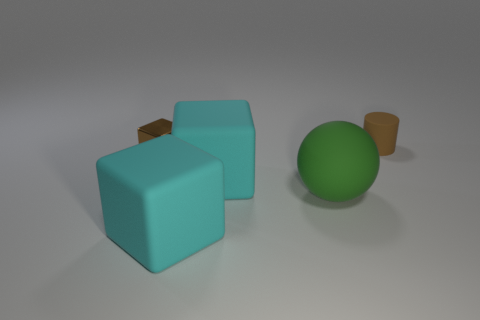There is a green thing that is made of the same material as the brown cylinder; what size is it?
Keep it short and to the point. Large. Is the number of tiny gray balls greater than the number of small brown matte cylinders?
Ensure brevity in your answer.  No. The large thing that is in front of the green object is what color?
Your response must be concise. Cyan. There is a cube that is both to the right of the small metallic thing and behind the large rubber ball; how big is it?
Make the answer very short. Large. What number of cyan cubes are the same size as the brown shiny cube?
Offer a terse response. 0. Does the big green object have the same shape as the brown metal thing?
Ensure brevity in your answer.  No. How many cyan matte cubes are in front of the rubber sphere?
Ensure brevity in your answer.  1. There is a brown thing that is on the right side of the green object that is right of the small metal object; what shape is it?
Your response must be concise. Cylinder. There is a small thing that is made of the same material as the large green sphere; what is its shape?
Make the answer very short. Cylinder. Is the size of the brown thing behind the tiny metal block the same as the brown object on the left side of the small brown cylinder?
Offer a very short reply. Yes. 